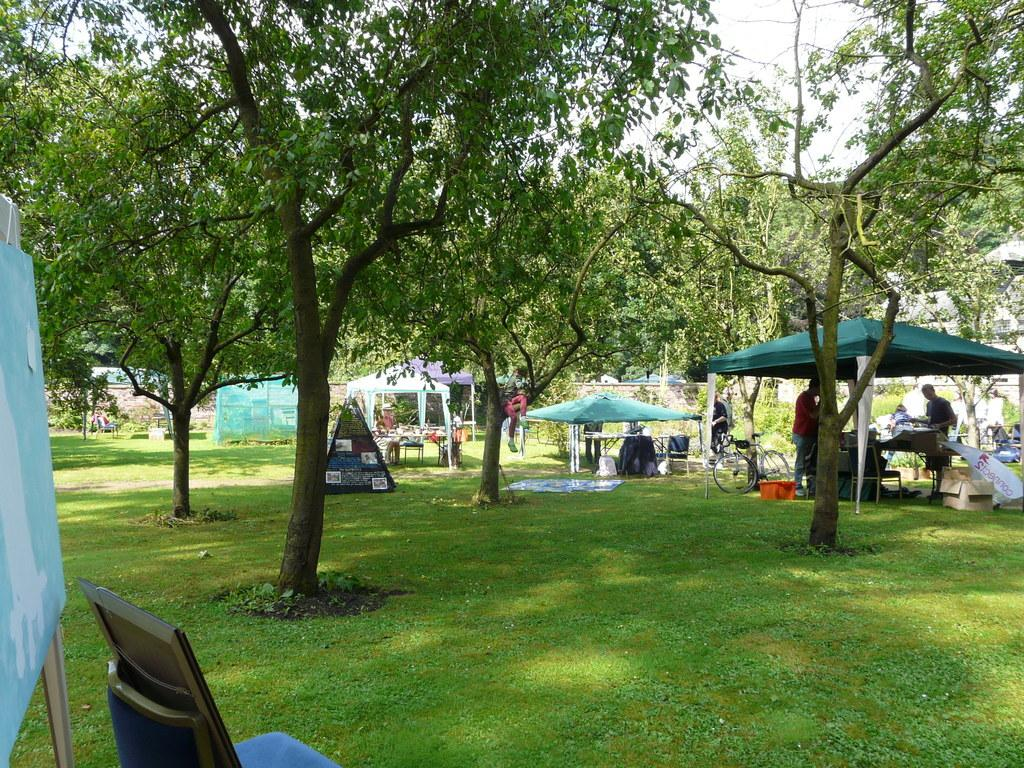What is located in the foreground of the image? There is a chair and a board in the foreground of the image. What can be seen in the background of the image? There are trees, tents, people, other items, houses, and the sky visible in the background of the image. What type of card is being used by the cook in the image? There is no cook or card present in the image. What is the carriage used for in the image? There is no carriage present in the image. 